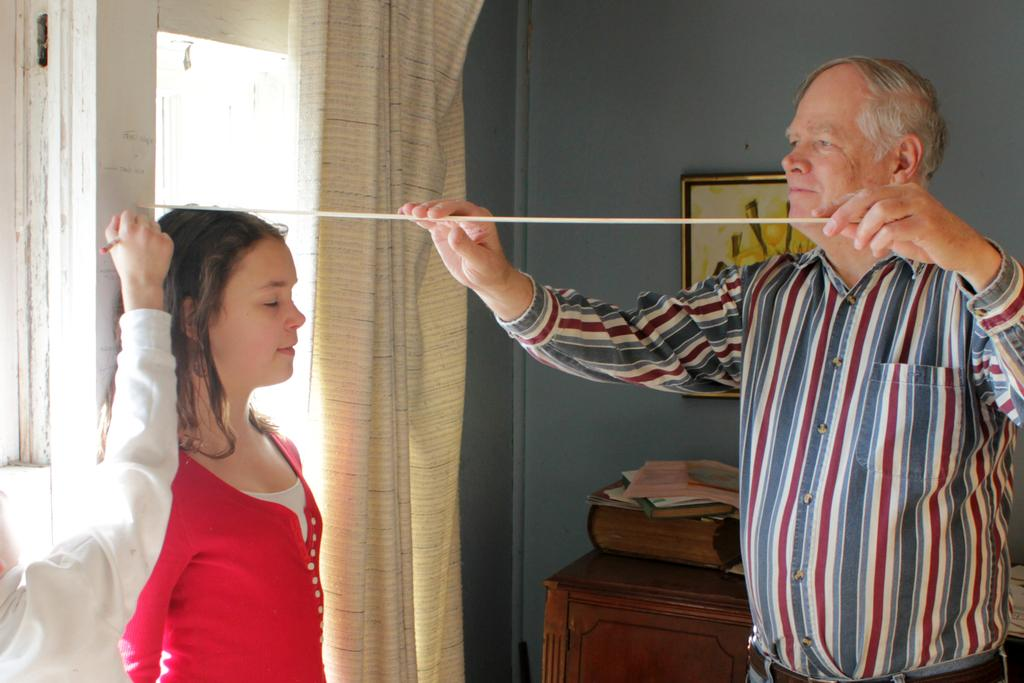What is the girl doing near the wall in the image? The girl is standing near the wall in the image. Who is present behind the girl? A man is behind the girl in the image. What is the man doing with the girl? The man is measuring the girl's height with a scale in the image. What can be seen behind the girl and the man? There is a table behind the girl in the image. What is hanging on the wall in the image? There is a painting frame hanging on the wall in the image. Can you see a car passing by on the railway in the image? There is no car or railway present in the image; it features a girl, a man, a table, and a painting frame hanging on the wall. What type of board is being used to measure the girl's height in the image? The man is using a scale to measure the girl's height, not a board. 